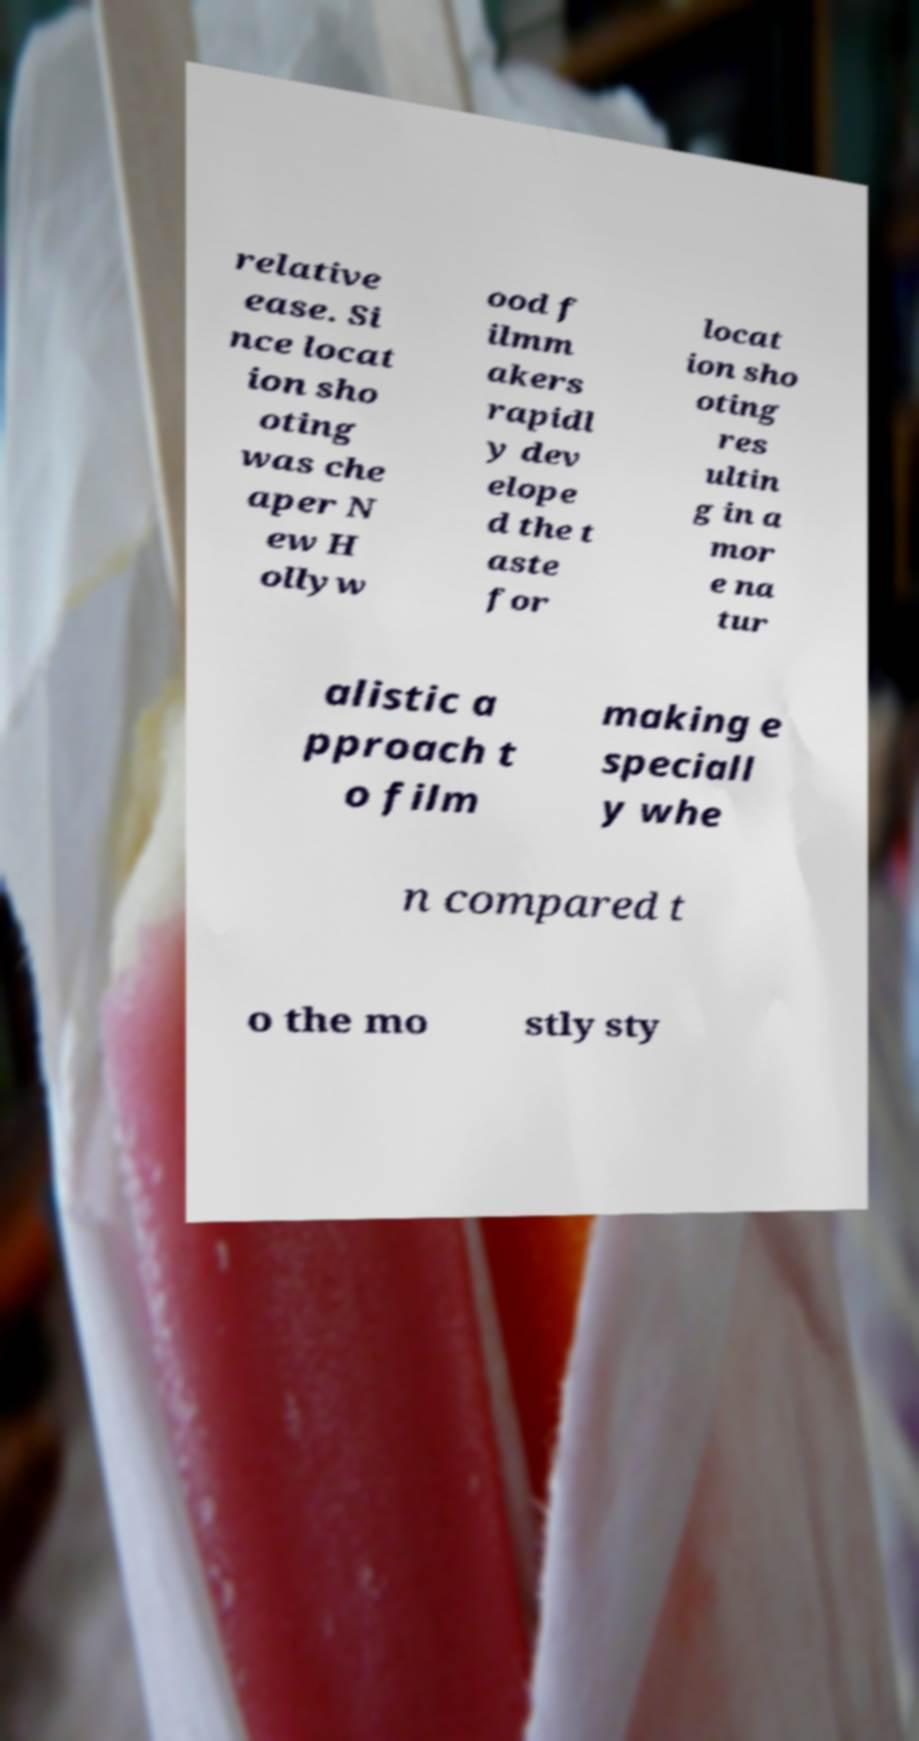For documentation purposes, I need the text within this image transcribed. Could you provide that? relative ease. Si nce locat ion sho oting was che aper N ew H ollyw ood f ilmm akers rapidl y dev elope d the t aste for locat ion sho oting res ultin g in a mor e na tur alistic a pproach t o film making e speciall y whe n compared t o the mo stly sty 